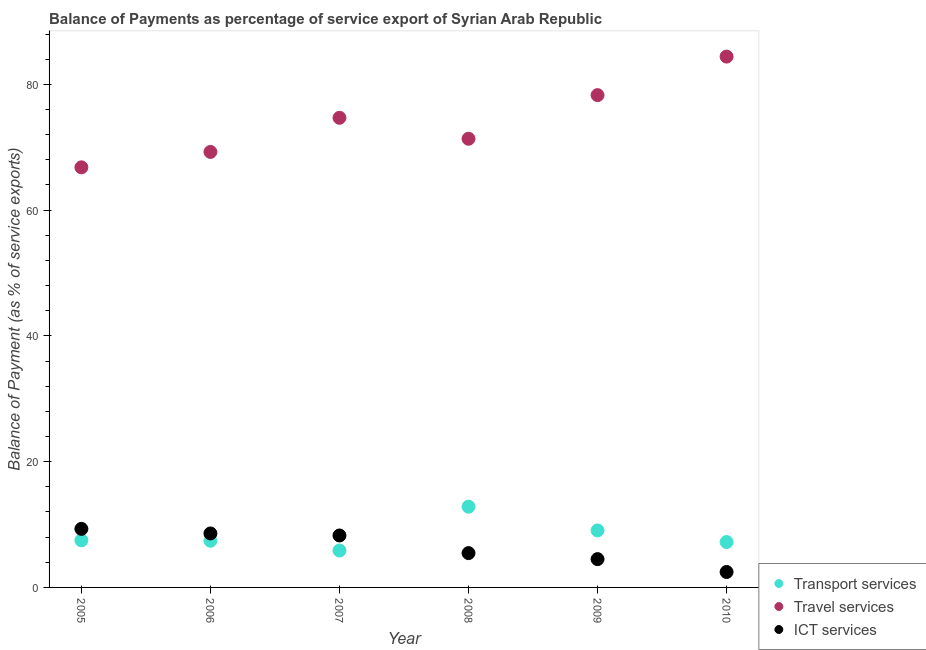What is the balance of payment of transport services in 2009?
Provide a succinct answer. 9.07. Across all years, what is the maximum balance of payment of ict services?
Keep it short and to the point. 9.31. Across all years, what is the minimum balance of payment of transport services?
Make the answer very short. 5.87. In which year was the balance of payment of ict services minimum?
Offer a terse response. 2010. What is the total balance of payment of ict services in the graph?
Make the answer very short. 38.57. What is the difference between the balance of payment of ict services in 2005 and that in 2006?
Ensure brevity in your answer.  0.73. What is the difference between the balance of payment of ict services in 2006 and the balance of payment of travel services in 2009?
Your answer should be compact. -69.7. What is the average balance of payment of travel services per year?
Offer a terse response. 74.13. In the year 2006, what is the difference between the balance of payment of ict services and balance of payment of travel services?
Your answer should be compact. -60.67. What is the ratio of the balance of payment of ict services in 2008 to that in 2010?
Give a very brief answer. 2.22. What is the difference between the highest and the second highest balance of payment of transport services?
Provide a succinct answer. 3.78. What is the difference between the highest and the lowest balance of payment of transport services?
Make the answer very short. 6.97. Does the balance of payment of travel services monotonically increase over the years?
Give a very brief answer. No. Is the balance of payment of travel services strictly greater than the balance of payment of transport services over the years?
Keep it short and to the point. Yes. Is the balance of payment of ict services strictly less than the balance of payment of transport services over the years?
Provide a succinct answer. No. What is the difference between two consecutive major ticks on the Y-axis?
Give a very brief answer. 20. Are the values on the major ticks of Y-axis written in scientific E-notation?
Make the answer very short. No. Where does the legend appear in the graph?
Ensure brevity in your answer.  Bottom right. How many legend labels are there?
Your answer should be compact. 3. How are the legend labels stacked?
Your answer should be compact. Vertical. What is the title of the graph?
Provide a succinct answer. Balance of Payments as percentage of service export of Syrian Arab Republic. Does "Capital account" appear as one of the legend labels in the graph?
Give a very brief answer. No. What is the label or title of the X-axis?
Your answer should be very brief. Year. What is the label or title of the Y-axis?
Give a very brief answer. Balance of Payment (as % of service exports). What is the Balance of Payment (as % of service exports) of Transport services in 2005?
Make the answer very short. 7.49. What is the Balance of Payment (as % of service exports) of Travel services in 2005?
Your response must be concise. 66.8. What is the Balance of Payment (as % of service exports) of ICT services in 2005?
Your response must be concise. 9.31. What is the Balance of Payment (as % of service exports) in Transport services in 2006?
Provide a succinct answer. 7.42. What is the Balance of Payment (as % of service exports) of Travel services in 2006?
Your response must be concise. 69.25. What is the Balance of Payment (as % of service exports) of ICT services in 2006?
Make the answer very short. 8.58. What is the Balance of Payment (as % of service exports) of Transport services in 2007?
Offer a terse response. 5.87. What is the Balance of Payment (as % of service exports) of Travel services in 2007?
Provide a short and direct response. 74.68. What is the Balance of Payment (as % of service exports) in ICT services in 2007?
Make the answer very short. 8.26. What is the Balance of Payment (as % of service exports) in Transport services in 2008?
Offer a very short reply. 12.84. What is the Balance of Payment (as % of service exports) of Travel services in 2008?
Make the answer very short. 71.35. What is the Balance of Payment (as % of service exports) in ICT services in 2008?
Provide a succinct answer. 5.46. What is the Balance of Payment (as % of service exports) of Transport services in 2009?
Your answer should be very brief. 9.07. What is the Balance of Payment (as % of service exports) in Travel services in 2009?
Your answer should be very brief. 78.29. What is the Balance of Payment (as % of service exports) in ICT services in 2009?
Provide a succinct answer. 4.5. What is the Balance of Payment (as % of service exports) in Transport services in 2010?
Make the answer very short. 7.22. What is the Balance of Payment (as % of service exports) of Travel services in 2010?
Offer a very short reply. 84.41. What is the Balance of Payment (as % of service exports) of ICT services in 2010?
Provide a short and direct response. 2.46. Across all years, what is the maximum Balance of Payment (as % of service exports) in Transport services?
Give a very brief answer. 12.84. Across all years, what is the maximum Balance of Payment (as % of service exports) of Travel services?
Keep it short and to the point. 84.41. Across all years, what is the maximum Balance of Payment (as % of service exports) of ICT services?
Keep it short and to the point. 9.31. Across all years, what is the minimum Balance of Payment (as % of service exports) in Transport services?
Make the answer very short. 5.87. Across all years, what is the minimum Balance of Payment (as % of service exports) in Travel services?
Keep it short and to the point. 66.8. Across all years, what is the minimum Balance of Payment (as % of service exports) of ICT services?
Your answer should be compact. 2.46. What is the total Balance of Payment (as % of service exports) in Transport services in the graph?
Ensure brevity in your answer.  49.91. What is the total Balance of Payment (as % of service exports) of Travel services in the graph?
Offer a very short reply. 444.79. What is the total Balance of Payment (as % of service exports) of ICT services in the graph?
Ensure brevity in your answer.  38.57. What is the difference between the Balance of Payment (as % of service exports) in Transport services in 2005 and that in 2006?
Your response must be concise. 0.07. What is the difference between the Balance of Payment (as % of service exports) in Travel services in 2005 and that in 2006?
Give a very brief answer. -2.45. What is the difference between the Balance of Payment (as % of service exports) in ICT services in 2005 and that in 2006?
Give a very brief answer. 0.73. What is the difference between the Balance of Payment (as % of service exports) of Transport services in 2005 and that in 2007?
Provide a short and direct response. 1.62. What is the difference between the Balance of Payment (as % of service exports) in Travel services in 2005 and that in 2007?
Make the answer very short. -7.88. What is the difference between the Balance of Payment (as % of service exports) in ICT services in 2005 and that in 2007?
Offer a terse response. 1.05. What is the difference between the Balance of Payment (as % of service exports) of Transport services in 2005 and that in 2008?
Ensure brevity in your answer.  -5.35. What is the difference between the Balance of Payment (as % of service exports) in Travel services in 2005 and that in 2008?
Your response must be concise. -4.54. What is the difference between the Balance of Payment (as % of service exports) in ICT services in 2005 and that in 2008?
Provide a short and direct response. 3.85. What is the difference between the Balance of Payment (as % of service exports) in Transport services in 2005 and that in 2009?
Keep it short and to the point. -1.57. What is the difference between the Balance of Payment (as % of service exports) in Travel services in 2005 and that in 2009?
Your response must be concise. -11.48. What is the difference between the Balance of Payment (as % of service exports) in ICT services in 2005 and that in 2009?
Your answer should be very brief. 4.81. What is the difference between the Balance of Payment (as % of service exports) of Transport services in 2005 and that in 2010?
Your answer should be compact. 0.28. What is the difference between the Balance of Payment (as % of service exports) of Travel services in 2005 and that in 2010?
Offer a terse response. -17.61. What is the difference between the Balance of Payment (as % of service exports) in ICT services in 2005 and that in 2010?
Your answer should be very brief. 6.86. What is the difference between the Balance of Payment (as % of service exports) of Transport services in 2006 and that in 2007?
Offer a terse response. 1.55. What is the difference between the Balance of Payment (as % of service exports) in Travel services in 2006 and that in 2007?
Make the answer very short. -5.43. What is the difference between the Balance of Payment (as % of service exports) in ICT services in 2006 and that in 2007?
Offer a very short reply. 0.32. What is the difference between the Balance of Payment (as % of service exports) in Transport services in 2006 and that in 2008?
Your answer should be very brief. -5.42. What is the difference between the Balance of Payment (as % of service exports) of Travel services in 2006 and that in 2008?
Provide a succinct answer. -2.09. What is the difference between the Balance of Payment (as % of service exports) in ICT services in 2006 and that in 2008?
Offer a very short reply. 3.13. What is the difference between the Balance of Payment (as % of service exports) of Transport services in 2006 and that in 2009?
Give a very brief answer. -1.65. What is the difference between the Balance of Payment (as % of service exports) of Travel services in 2006 and that in 2009?
Make the answer very short. -9.03. What is the difference between the Balance of Payment (as % of service exports) in ICT services in 2006 and that in 2009?
Give a very brief answer. 4.08. What is the difference between the Balance of Payment (as % of service exports) of Transport services in 2006 and that in 2010?
Provide a succinct answer. 0.2. What is the difference between the Balance of Payment (as % of service exports) in Travel services in 2006 and that in 2010?
Provide a succinct answer. -15.16. What is the difference between the Balance of Payment (as % of service exports) in ICT services in 2006 and that in 2010?
Offer a terse response. 6.13. What is the difference between the Balance of Payment (as % of service exports) of Transport services in 2007 and that in 2008?
Offer a terse response. -6.97. What is the difference between the Balance of Payment (as % of service exports) of Travel services in 2007 and that in 2008?
Your answer should be compact. 3.33. What is the difference between the Balance of Payment (as % of service exports) in ICT services in 2007 and that in 2008?
Your answer should be very brief. 2.8. What is the difference between the Balance of Payment (as % of service exports) of Transport services in 2007 and that in 2009?
Give a very brief answer. -3.2. What is the difference between the Balance of Payment (as % of service exports) of Travel services in 2007 and that in 2009?
Make the answer very short. -3.6. What is the difference between the Balance of Payment (as % of service exports) of ICT services in 2007 and that in 2009?
Provide a succinct answer. 3.76. What is the difference between the Balance of Payment (as % of service exports) in Transport services in 2007 and that in 2010?
Your response must be concise. -1.35. What is the difference between the Balance of Payment (as % of service exports) in Travel services in 2007 and that in 2010?
Your answer should be very brief. -9.73. What is the difference between the Balance of Payment (as % of service exports) in ICT services in 2007 and that in 2010?
Your response must be concise. 5.81. What is the difference between the Balance of Payment (as % of service exports) in Transport services in 2008 and that in 2009?
Provide a short and direct response. 3.78. What is the difference between the Balance of Payment (as % of service exports) of Travel services in 2008 and that in 2009?
Make the answer very short. -6.94. What is the difference between the Balance of Payment (as % of service exports) in ICT services in 2008 and that in 2009?
Ensure brevity in your answer.  0.96. What is the difference between the Balance of Payment (as % of service exports) of Transport services in 2008 and that in 2010?
Your answer should be very brief. 5.63. What is the difference between the Balance of Payment (as % of service exports) in Travel services in 2008 and that in 2010?
Ensure brevity in your answer.  -13.07. What is the difference between the Balance of Payment (as % of service exports) in ICT services in 2008 and that in 2010?
Offer a terse response. 3. What is the difference between the Balance of Payment (as % of service exports) of Transport services in 2009 and that in 2010?
Ensure brevity in your answer.  1.85. What is the difference between the Balance of Payment (as % of service exports) in Travel services in 2009 and that in 2010?
Make the answer very short. -6.13. What is the difference between the Balance of Payment (as % of service exports) of ICT services in 2009 and that in 2010?
Provide a succinct answer. 2.05. What is the difference between the Balance of Payment (as % of service exports) of Transport services in 2005 and the Balance of Payment (as % of service exports) of Travel services in 2006?
Your response must be concise. -61.76. What is the difference between the Balance of Payment (as % of service exports) of Transport services in 2005 and the Balance of Payment (as % of service exports) of ICT services in 2006?
Keep it short and to the point. -1.09. What is the difference between the Balance of Payment (as % of service exports) in Travel services in 2005 and the Balance of Payment (as % of service exports) in ICT services in 2006?
Offer a very short reply. 58.22. What is the difference between the Balance of Payment (as % of service exports) in Transport services in 2005 and the Balance of Payment (as % of service exports) in Travel services in 2007?
Make the answer very short. -67.19. What is the difference between the Balance of Payment (as % of service exports) of Transport services in 2005 and the Balance of Payment (as % of service exports) of ICT services in 2007?
Your response must be concise. -0.77. What is the difference between the Balance of Payment (as % of service exports) in Travel services in 2005 and the Balance of Payment (as % of service exports) in ICT services in 2007?
Keep it short and to the point. 58.54. What is the difference between the Balance of Payment (as % of service exports) of Transport services in 2005 and the Balance of Payment (as % of service exports) of Travel services in 2008?
Offer a terse response. -63.86. What is the difference between the Balance of Payment (as % of service exports) of Transport services in 2005 and the Balance of Payment (as % of service exports) of ICT services in 2008?
Provide a succinct answer. 2.03. What is the difference between the Balance of Payment (as % of service exports) of Travel services in 2005 and the Balance of Payment (as % of service exports) of ICT services in 2008?
Provide a succinct answer. 61.35. What is the difference between the Balance of Payment (as % of service exports) of Transport services in 2005 and the Balance of Payment (as % of service exports) of Travel services in 2009?
Ensure brevity in your answer.  -70.8. What is the difference between the Balance of Payment (as % of service exports) in Transport services in 2005 and the Balance of Payment (as % of service exports) in ICT services in 2009?
Your answer should be very brief. 2.99. What is the difference between the Balance of Payment (as % of service exports) of Travel services in 2005 and the Balance of Payment (as % of service exports) of ICT services in 2009?
Make the answer very short. 62.3. What is the difference between the Balance of Payment (as % of service exports) of Transport services in 2005 and the Balance of Payment (as % of service exports) of Travel services in 2010?
Your answer should be very brief. -76.92. What is the difference between the Balance of Payment (as % of service exports) of Transport services in 2005 and the Balance of Payment (as % of service exports) of ICT services in 2010?
Make the answer very short. 5.04. What is the difference between the Balance of Payment (as % of service exports) in Travel services in 2005 and the Balance of Payment (as % of service exports) in ICT services in 2010?
Your answer should be compact. 64.35. What is the difference between the Balance of Payment (as % of service exports) of Transport services in 2006 and the Balance of Payment (as % of service exports) of Travel services in 2007?
Provide a short and direct response. -67.26. What is the difference between the Balance of Payment (as % of service exports) in Transport services in 2006 and the Balance of Payment (as % of service exports) in ICT services in 2007?
Ensure brevity in your answer.  -0.84. What is the difference between the Balance of Payment (as % of service exports) of Travel services in 2006 and the Balance of Payment (as % of service exports) of ICT services in 2007?
Offer a very short reply. 60.99. What is the difference between the Balance of Payment (as % of service exports) of Transport services in 2006 and the Balance of Payment (as % of service exports) of Travel services in 2008?
Ensure brevity in your answer.  -63.93. What is the difference between the Balance of Payment (as % of service exports) of Transport services in 2006 and the Balance of Payment (as % of service exports) of ICT services in 2008?
Your answer should be very brief. 1.96. What is the difference between the Balance of Payment (as % of service exports) in Travel services in 2006 and the Balance of Payment (as % of service exports) in ICT services in 2008?
Your answer should be compact. 63.8. What is the difference between the Balance of Payment (as % of service exports) of Transport services in 2006 and the Balance of Payment (as % of service exports) of Travel services in 2009?
Make the answer very short. -70.87. What is the difference between the Balance of Payment (as % of service exports) in Transport services in 2006 and the Balance of Payment (as % of service exports) in ICT services in 2009?
Keep it short and to the point. 2.92. What is the difference between the Balance of Payment (as % of service exports) of Travel services in 2006 and the Balance of Payment (as % of service exports) of ICT services in 2009?
Provide a short and direct response. 64.75. What is the difference between the Balance of Payment (as % of service exports) of Transport services in 2006 and the Balance of Payment (as % of service exports) of Travel services in 2010?
Provide a succinct answer. -76.99. What is the difference between the Balance of Payment (as % of service exports) of Transport services in 2006 and the Balance of Payment (as % of service exports) of ICT services in 2010?
Give a very brief answer. 4.97. What is the difference between the Balance of Payment (as % of service exports) of Travel services in 2006 and the Balance of Payment (as % of service exports) of ICT services in 2010?
Keep it short and to the point. 66.8. What is the difference between the Balance of Payment (as % of service exports) of Transport services in 2007 and the Balance of Payment (as % of service exports) of Travel services in 2008?
Provide a succinct answer. -65.48. What is the difference between the Balance of Payment (as % of service exports) in Transport services in 2007 and the Balance of Payment (as % of service exports) in ICT services in 2008?
Offer a terse response. 0.41. What is the difference between the Balance of Payment (as % of service exports) in Travel services in 2007 and the Balance of Payment (as % of service exports) in ICT services in 2008?
Your answer should be very brief. 69.22. What is the difference between the Balance of Payment (as % of service exports) of Transport services in 2007 and the Balance of Payment (as % of service exports) of Travel services in 2009?
Your response must be concise. -72.42. What is the difference between the Balance of Payment (as % of service exports) of Transport services in 2007 and the Balance of Payment (as % of service exports) of ICT services in 2009?
Ensure brevity in your answer.  1.37. What is the difference between the Balance of Payment (as % of service exports) in Travel services in 2007 and the Balance of Payment (as % of service exports) in ICT services in 2009?
Give a very brief answer. 70.18. What is the difference between the Balance of Payment (as % of service exports) in Transport services in 2007 and the Balance of Payment (as % of service exports) in Travel services in 2010?
Offer a very short reply. -78.55. What is the difference between the Balance of Payment (as % of service exports) of Transport services in 2007 and the Balance of Payment (as % of service exports) of ICT services in 2010?
Offer a very short reply. 3.41. What is the difference between the Balance of Payment (as % of service exports) in Travel services in 2007 and the Balance of Payment (as % of service exports) in ICT services in 2010?
Keep it short and to the point. 72.23. What is the difference between the Balance of Payment (as % of service exports) in Transport services in 2008 and the Balance of Payment (as % of service exports) in Travel services in 2009?
Make the answer very short. -65.45. What is the difference between the Balance of Payment (as % of service exports) of Transport services in 2008 and the Balance of Payment (as % of service exports) of ICT services in 2009?
Your answer should be compact. 8.34. What is the difference between the Balance of Payment (as % of service exports) in Travel services in 2008 and the Balance of Payment (as % of service exports) in ICT services in 2009?
Offer a terse response. 66.85. What is the difference between the Balance of Payment (as % of service exports) of Transport services in 2008 and the Balance of Payment (as % of service exports) of Travel services in 2010?
Keep it short and to the point. -71.57. What is the difference between the Balance of Payment (as % of service exports) in Transport services in 2008 and the Balance of Payment (as % of service exports) in ICT services in 2010?
Your answer should be compact. 10.39. What is the difference between the Balance of Payment (as % of service exports) of Travel services in 2008 and the Balance of Payment (as % of service exports) of ICT services in 2010?
Provide a succinct answer. 68.89. What is the difference between the Balance of Payment (as % of service exports) in Transport services in 2009 and the Balance of Payment (as % of service exports) in Travel services in 2010?
Your response must be concise. -75.35. What is the difference between the Balance of Payment (as % of service exports) of Transport services in 2009 and the Balance of Payment (as % of service exports) of ICT services in 2010?
Your answer should be very brief. 6.61. What is the difference between the Balance of Payment (as % of service exports) of Travel services in 2009 and the Balance of Payment (as % of service exports) of ICT services in 2010?
Ensure brevity in your answer.  75.83. What is the average Balance of Payment (as % of service exports) in Transport services per year?
Offer a very short reply. 8.32. What is the average Balance of Payment (as % of service exports) in Travel services per year?
Provide a succinct answer. 74.13. What is the average Balance of Payment (as % of service exports) of ICT services per year?
Provide a succinct answer. 6.43. In the year 2005, what is the difference between the Balance of Payment (as % of service exports) of Transport services and Balance of Payment (as % of service exports) of Travel services?
Provide a short and direct response. -59.31. In the year 2005, what is the difference between the Balance of Payment (as % of service exports) in Transport services and Balance of Payment (as % of service exports) in ICT services?
Offer a terse response. -1.82. In the year 2005, what is the difference between the Balance of Payment (as % of service exports) in Travel services and Balance of Payment (as % of service exports) in ICT services?
Offer a very short reply. 57.49. In the year 2006, what is the difference between the Balance of Payment (as % of service exports) in Transport services and Balance of Payment (as % of service exports) in Travel services?
Give a very brief answer. -61.83. In the year 2006, what is the difference between the Balance of Payment (as % of service exports) of Transport services and Balance of Payment (as % of service exports) of ICT services?
Offer a very short reply. -1.16. In the year 2006, what is the difference between the Balance of Payment (as % of service exports) of Travel services and Balance of Payment (as % of service exports) of ICT services?
Your response must be concise. 60.67. In the year 2007, what is the difference between the Balance of Payment (as % of service exports) in Transport services and Balance of Payment (as % of service exports) in Travel services?
Offer a terse response. -68.81. In the year 2007, what is the difference between the Balance of Payment (as % of service exports) of Transport services and Balance of Payment (as % of service exports) of ICT services?
Your answer should be compact. -2.39. In the year 2007, what is the difference between the Balance of Payment (as % of service exports) in Travel services and Balance of Payment (as % of service exports) in ICT services?
Make the answer very short. 66.42. In the year 2008, what is the difference between the Balance of Payment (as % of service exports) of Transport services and Balance of Payment (as % of service exports) of Travel services?
Your response must be concise. -58.51. In the year 2008, what is the difference between the Balance of Payment (as % of service exports) of Transport services and Balance of Payment (as % of service exports) of ICT services?
Give a very brief answer. 7.38. In the year 2008, what is the difference between the Balance of Payment (as % of service exports) of Travel services and Balance of Payment (as % of service exports) of ICT services?
Your answer should be compact. 65.89. In the year 2009, what is the difference between the Balance of Payment (as % of service exports) in Transport services and Balance of Payment (as % of service exports) in Travel services?
Provide a short and direct response. -69.22. In the year 2009, what is the difference between the Balance of Payment (as % of service exports) of Transport services and Balance of Payment (as % of service exports) of ICT services?
Your answer should be very brief. 4.57. In the year 2009, what is the difference between the Balance of Payment (as % of service exports) of Travel services and Balance of Payment (as % of service exports) of ICT services?
Your response must be concise. 73.79. In the year 2010, what is the difference between the Balance of Payment (as % of service exports) in Transport services and Balance of Payment (as % of service exports) in Travel services?
Your answer should be very brief. -77.2. In the year 2010, what is the difference between the Balance of Payment (as % of service exports) in Transport services and Balance of Payment (as % of service exports) in ICT services?
Your response must be concise. 4.76. In the year 2010, what is the difference between the Balance of Payment (as % of service exports) in Travel services and Balance of Payment (as % of service exports) in ICT services?
Ensure brevity in your answer.  81.96. What is the ratio of the Balance of Payment (as % of service exports) in Transport services in 2005 to that in 2006?
Your response must be concise. 1.01. What is the ratio of the Balance of Payment (as % of service exports) of Travel services in 2005 to that in 2006?
Give a very brief answer. 0.96. What is the ratio of the Balance of Payment (as % of service exports) in ICT services in 2005 to that in 2006?
Give a very brief answer. 1.08. What is the ratio of the Balance of Payment (as % of service exports) in Transport services in 2005 to that in 2007?
Keep it short and to the point. 1.28. What is the ratio of the Balance of Payment (as % of service exports) in Travel services in 2005 to that in 2007?
Keep it short and to the point. 0.89. What is the ratio of the Balance of Payment (as % of service exports) of ICT services in 2005 to that in 2007?
Provide a short and direct response. 1.13. What is the ratio of the Balance of Payment (as % of service exports) in Transport services in 2005 to that in 2008?
Your answer should be very brief. 0.58. What is the ratio of the Balance of Payment (as % of service exports) of Travel services in 2005 to that in 2008?
Offer a terse response. 0.94. What is the ratio of the Balance of Payment (as % of service exports) in ICT services in 2005 to that in 2008?
Your response must be concise. 1.71. What is the ratio of the Balance of Payment (as % of service exports) of Transport services in 2005 to that in 2009?
Keep it short and to the point. 0.83. What is the ratio of the Balance of Payment (as % of service exports) in Travel services in 2005 to that in 2009?
Give a very brief answer. 0.85. What is the ratio of the Balance of Payment (as % of service exports) in ICT services in 2005 to that in 2009?
Ensure brevity in your answer.  2.07. What is the ratio of the Balance of Payment (as % of service exports) in Transport services in 2005 to that in 2010?
Make the answer very short. 1.04. What is the ratio of the Balance of Payment (as % of service exports) in Travel services in 2005 to that in 2010?
Offer a very short reply. 0.79. What is the ratio of the Balance of Payment (as % of service exports) in ICT services in 2005 to that in 2010?
Your answer should be very brief. 3.79. What is the ratio of the Balance of Payment (as % of service exports) of Transport services in 2006 to that in 2007?
Make the answer very short. 1.26. What is the ratio of the Balance of Payment (as % of service exports) in Travel services in 2006 to that in 2007?
Give a very brief answer. 0.93. What is the ratio of the Balance of Payment (as % of service exports) of ICT services in 2006 to that in 2007?
Ensure brevity in your answer.  1.04. What is the ratio of the Balance of Payment (as % of service exports) in Transport services in 2006 to that in 2008?
Offer a terse response. 0.58. What is the ratio of the Balance of Payment (as % of service exports) of Travel services in 2006 to that in 2008?
Provide a succinct answer. 0.97. What is the ratio of the Balance of Payment (as % of service exports) in ICT services in 2006 to that in 2008?
Make the answer very short. 1.57. What is the ratio of the Balance of Payment (as % of service exports) of Transport services in 2006 to that in 2009?
Give a very brief answer. 0.82. What is the ratio of the Balance of Payment (as % of service exports) in Travel services in 2006 to that in 2009?
Give a very brief answer. 0.88. What is the ratio of the Balance of Payment (as % of service exports) in ICT services in 2006 to that in 2009?
Provide a short and direct response. 1.91. What is the ratio of the Balance of Payment (as % of service exports) of Transport services in 2006 to that in 2010?
Ensure brevity in your answer.  1.03. What is the ratio of the Balance of Payment (as % of service exports) in Travel services in 2006 to that in 2010?
Your answer should be very brief. 0.82. What is the ratio of the Balance of Payment (as % of service exports) of ICT services in 2006 to that in 2010?
Your answer should be very brief. 3.5. What is the ratio of the Balance of Payment (as % of service exports) in Transport services in 2007 to that in 2008?
Provide a succinct answer. 0.46. What is the ratio of the Balance of Payment (as % of service exports) of Travel services in 2007 to that in 2008?
Offer a very short reply. 1.05. What is the ratio of the Balance of Payment (as % of service exports) of ICT services in 2007 to that in 2008?
Offer a very short reply. 1.51. What is the ratio of the Balance of Payment (as % of service exports) in Transport services in 2007 to that in 2009?
Keep it short and to the point. 0.65. What is the ratio of the Balance of Payment (as % of service exports) of Travel services in 2007 to that in 2009?
Give a very brief answer. 0.95. What is the ratio of the Balance of Payment (as % of service exports) of ICT services in 2007 to that in 2009?
Offer a very short reply. 1.84. What is the ratio of the Balance of Payment (as % of service exports) in Transport services in 2007 to that in 2010?
Make the answer very short. 0.81. What is the ratio of the Balance of Payment (as % of service exports) in Travel services in 2007 to that in 2010?
Offer a very short reply. 0.88. What is the ratio of the Balance of Payment (as % of service exports) in ICT services in 2007 to that in 2010?
Your answer should be compact. 3.36. What is the ratio of the Balance of Payment (as % of service exports) of Transport services in 2008 to that in 2009?
Keep it short and to the point. 1.42. What is the ratio of the Balance of Payment (as % of service exports) in Travel services in 2008 to that in 2009?
Provide a short and direct response. 0.91. What is the ratio of the Balance of Payment (as % of service exports) of ICT services in 2008 to that in 2009?
Give a very brief answer. 1.21. What is the ratio of the Balance of Payment (as % of service exports) in Transport services in 2008 to that in 2010?
Ensure brevity in your answer.  1.78. What is the ratio of the Balance of Payment (as % of service exports) in Travel services in 2008 to that in 2010?
Give a very brief answer. 0.85. What is the ratio of the Balance of Payment (as % of service exports) in ICT services in 2008 to that in 2010?
Provide a succinct answer. 2.22. What is the ratio of the Balance of Payment (as % of service exports) in Transport services in 2009 to that in 2010?
Ensure brevity in your answer.  1.26. What is the ratio of the Balance of Payment (as % of service exports) in Travel services in 2009 to that in 2010?
Provide a short and direct response. 0.93. What is the ratio of the Balance of Payment (as % of service exports) in ICT services in 2009 to that in 2010?
Make the answer very short. 1.83. What is the difference between the highest and the second highest Balance of Payment (as % of service exports) in Transport services?
Give a very brief answer. 3.78. What is the difference between the highest and the second highest Balance of Payment (as % of service exports) in Travel services?
Your answer should be compact. 6.13. What is the difference between the highest and the second highest Balance of Payment (as % of service exports) of ICT services?
Offer a very short reply. 0.73. What is the difference between the highest and the lowest Balance of Payment (as % of service exports) of Transport services?
Offer a very short reply. 6.97. What is the difference between the highest and the lowest Balance of Payment (as % of service exports) in Travel services?
Your answer should be compact. 17.61. What is the difference between the highest and the lowest Balance of Payment (as % of service exports) of ICT services?
Make the answer very short. 6.86. 